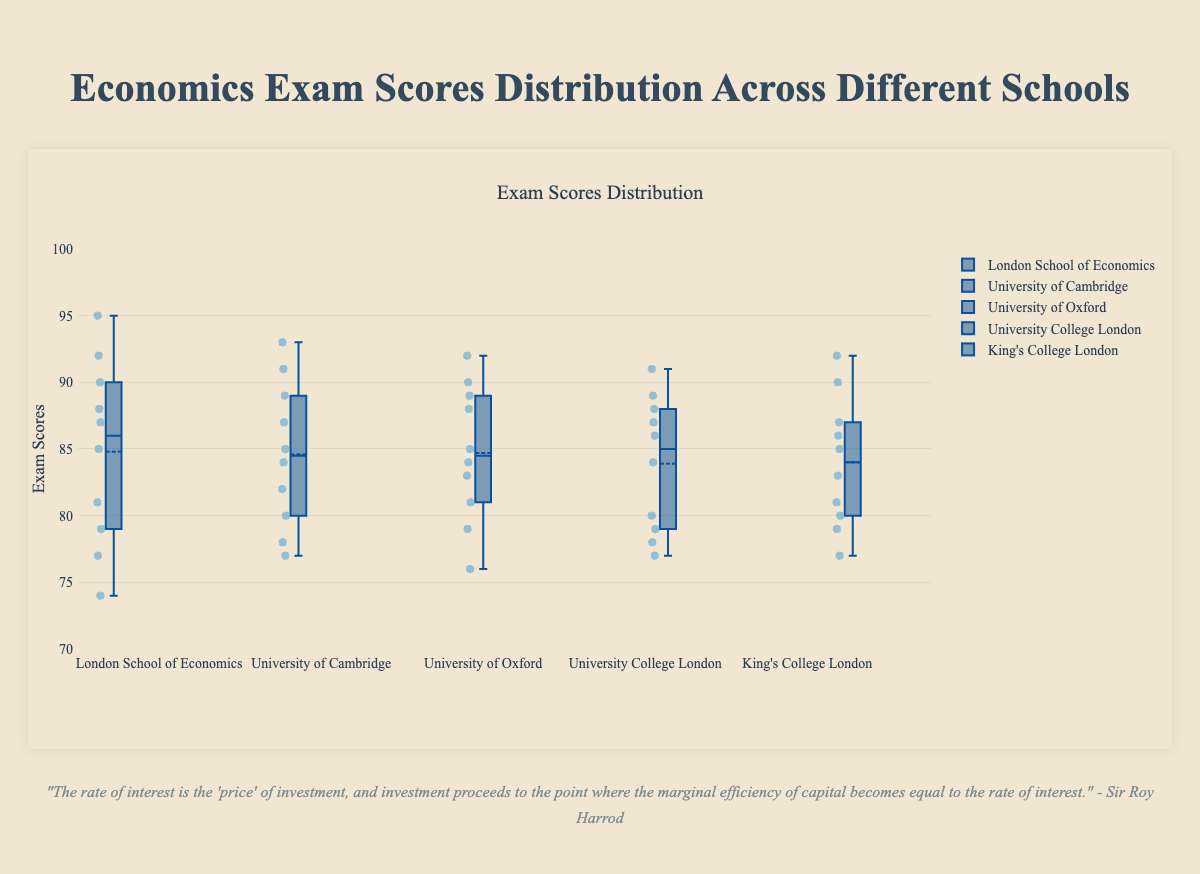What is the title of the plot? The title of the plot is displayed at the top and provides an overview of what the figure represents. The title reads "Economics Exam Scores Distribution Across Different Schools."
Answer: Economics Exam Scores Distribution Across Different Schools What is the y-axis representing in this plot? The y-axis represents the exam scores, as indicated by the label on the left side of the axis.
Answer: Exam Scores Which school has the highest median exam score? The median score is the central line inside the box in each plot. The London School of Economics has the highest median, as its median line is higher than those of other schools.
Answer: London School of Economics Which school has the largest range of exam scores? The range can be determined by the length of the box plot whiskers. The London School of Economics has the largest range, extending from 74 to 95, which shows a larger spread in scores.
Answer: London School of Economics What is the interquartile range (IQR) for the University of Oxford? The IQR is the difference between the third quartile (Q3) and the first quartile (Q1). For the University of Oxford, Q3 is at 89, and Q1 is at 79. So, IQR is 89 - 79.
Answer: 10 Which school has the lowest minimum score? The lowest minimum score is denoted by the lowest point on the whisker. The University of Oxford has the lowest minimum score which is 76.
Answer: University of Oxford Compare the medians of University College London and King's College London. Which one is higher? Comparing the median lines inside the boxes, University College London's median is slightly higher than King's College London's median.
Answer: University College London What's the upper quartile (Q3) score for the University of Cambridge? The upper quartile (Q3) is the top edge of the box. For the University of Cambridge, Q3 is at 89.
Answer: 89 What is the mean exam score for King's College London? The mean score is represented by the small circle within the box. For King's College London, the mean score is around 84.
Answer: 84 